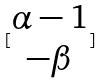<formula> <loc_0><loc_0><loc_500><loc_500>[ \begin{matrix} \alpha - 1 \\ - \beta \end{matrix} ]</formula> 